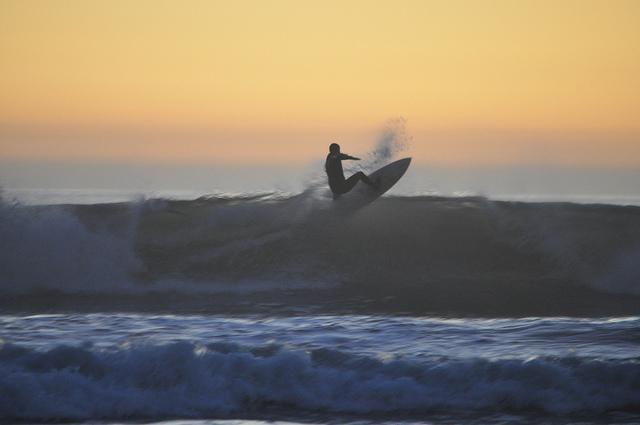How many baby elephants are there?
Give a very brief answer. 0. 